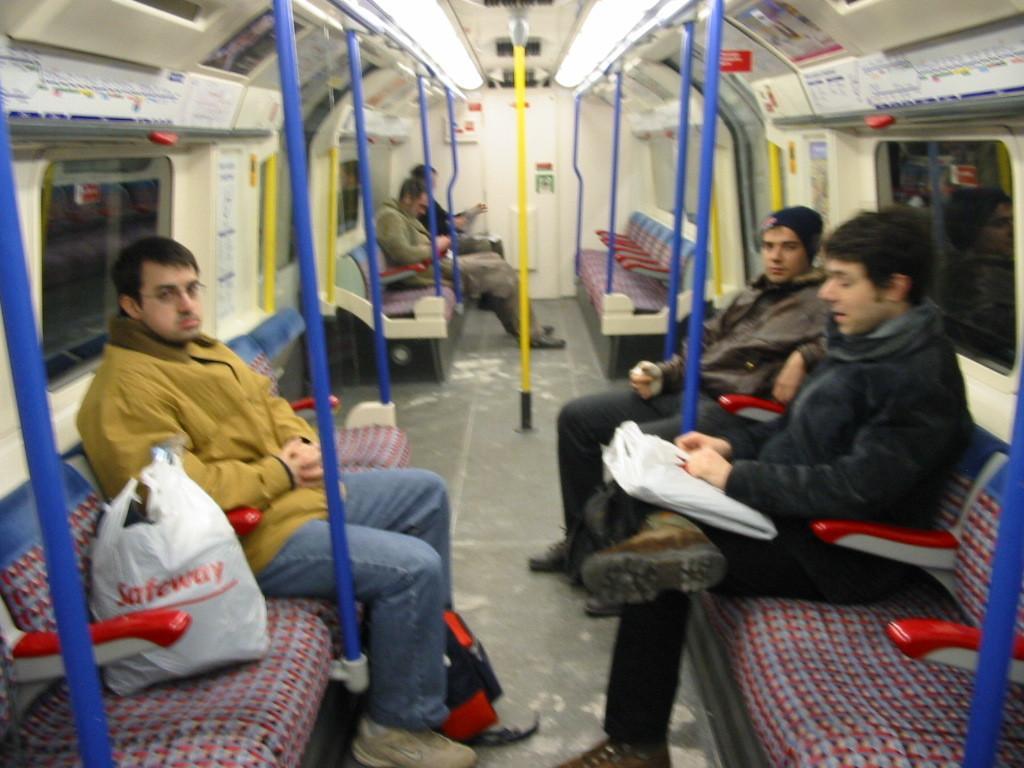How would you summarize this image in a sentence or two? This image consists of few persons sitting in a train. In the middle, there are poles in blue and yellow colors. On the left and right, there are windows and seats. At the top, there is a roof. At the bottom, there is a floor. 